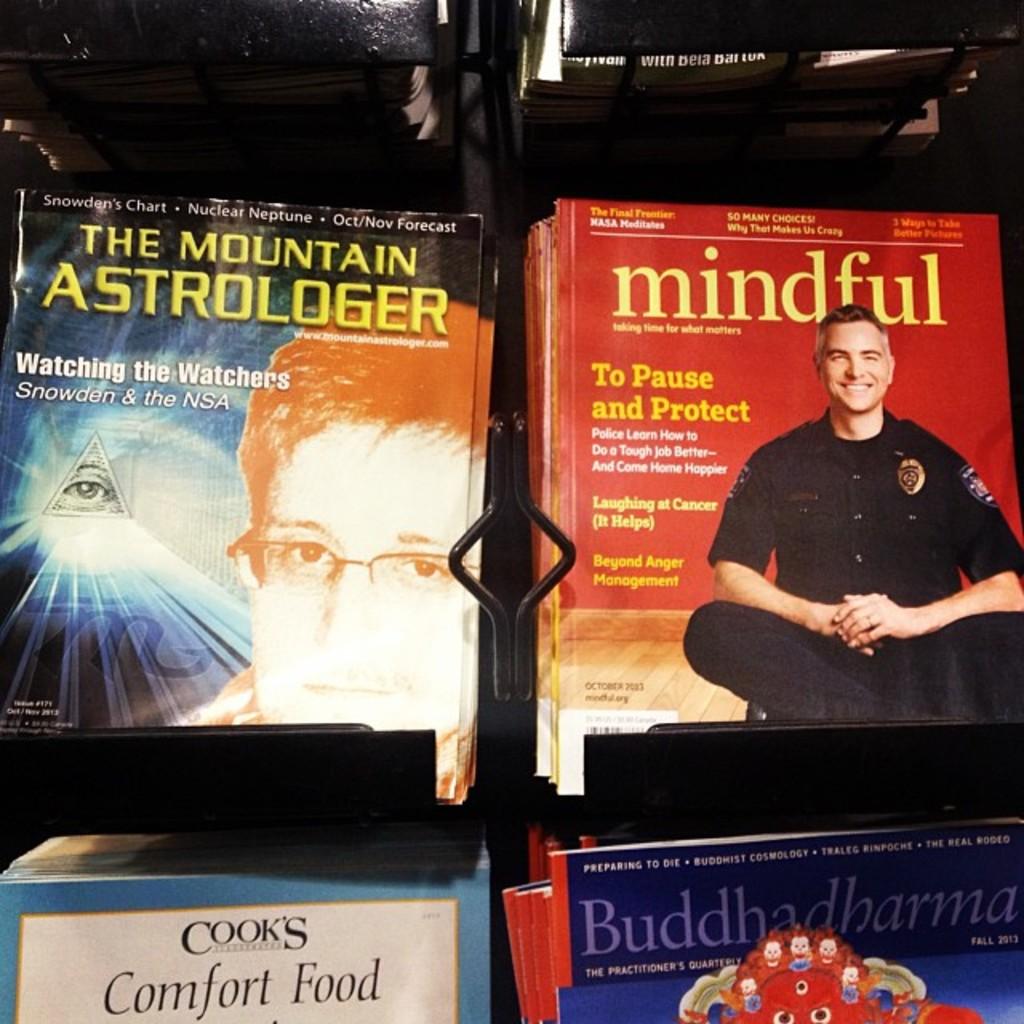What is the title of the magazine in the upper right?
Ensure brevity in your answer.  Mindful. 